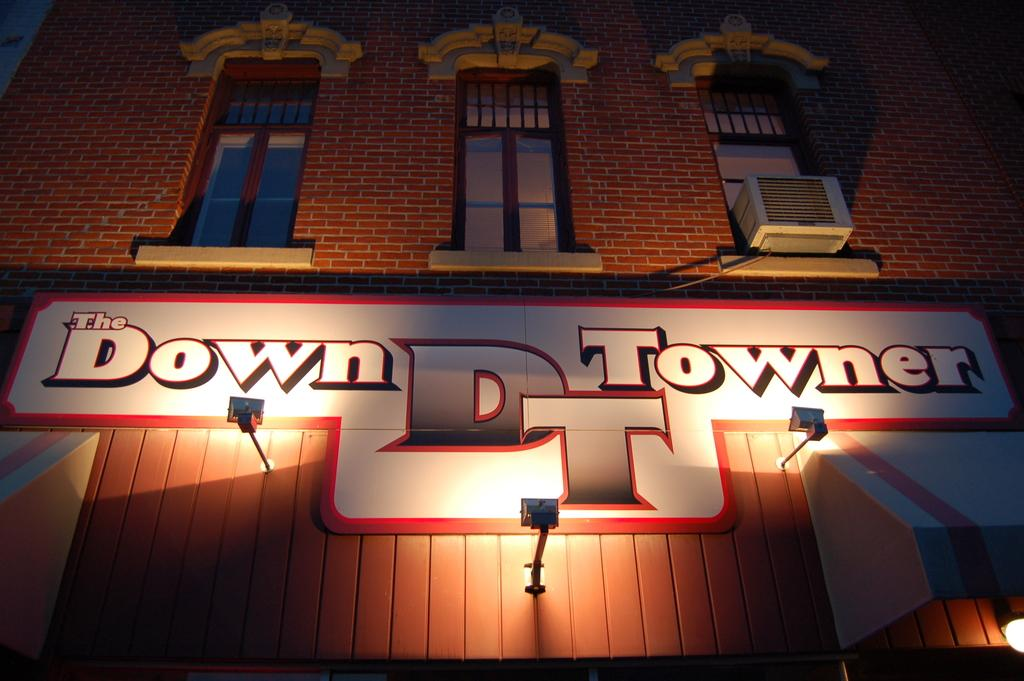What type of structure is present in the image? There is a building in the image. What feature of the building is mentioned in the facts? The building has windows. What other object is present in the image? There is a board in the image. Are there any lighting elements in the image? Yes, there are lights in the image. Can you describe the unspecified object in the image? Unfortunately, the facts do not provide enough information to describe the unspecified object. How many streets can be seen in the middle of the image? There is no mention of streets in the image or the provided facts. 